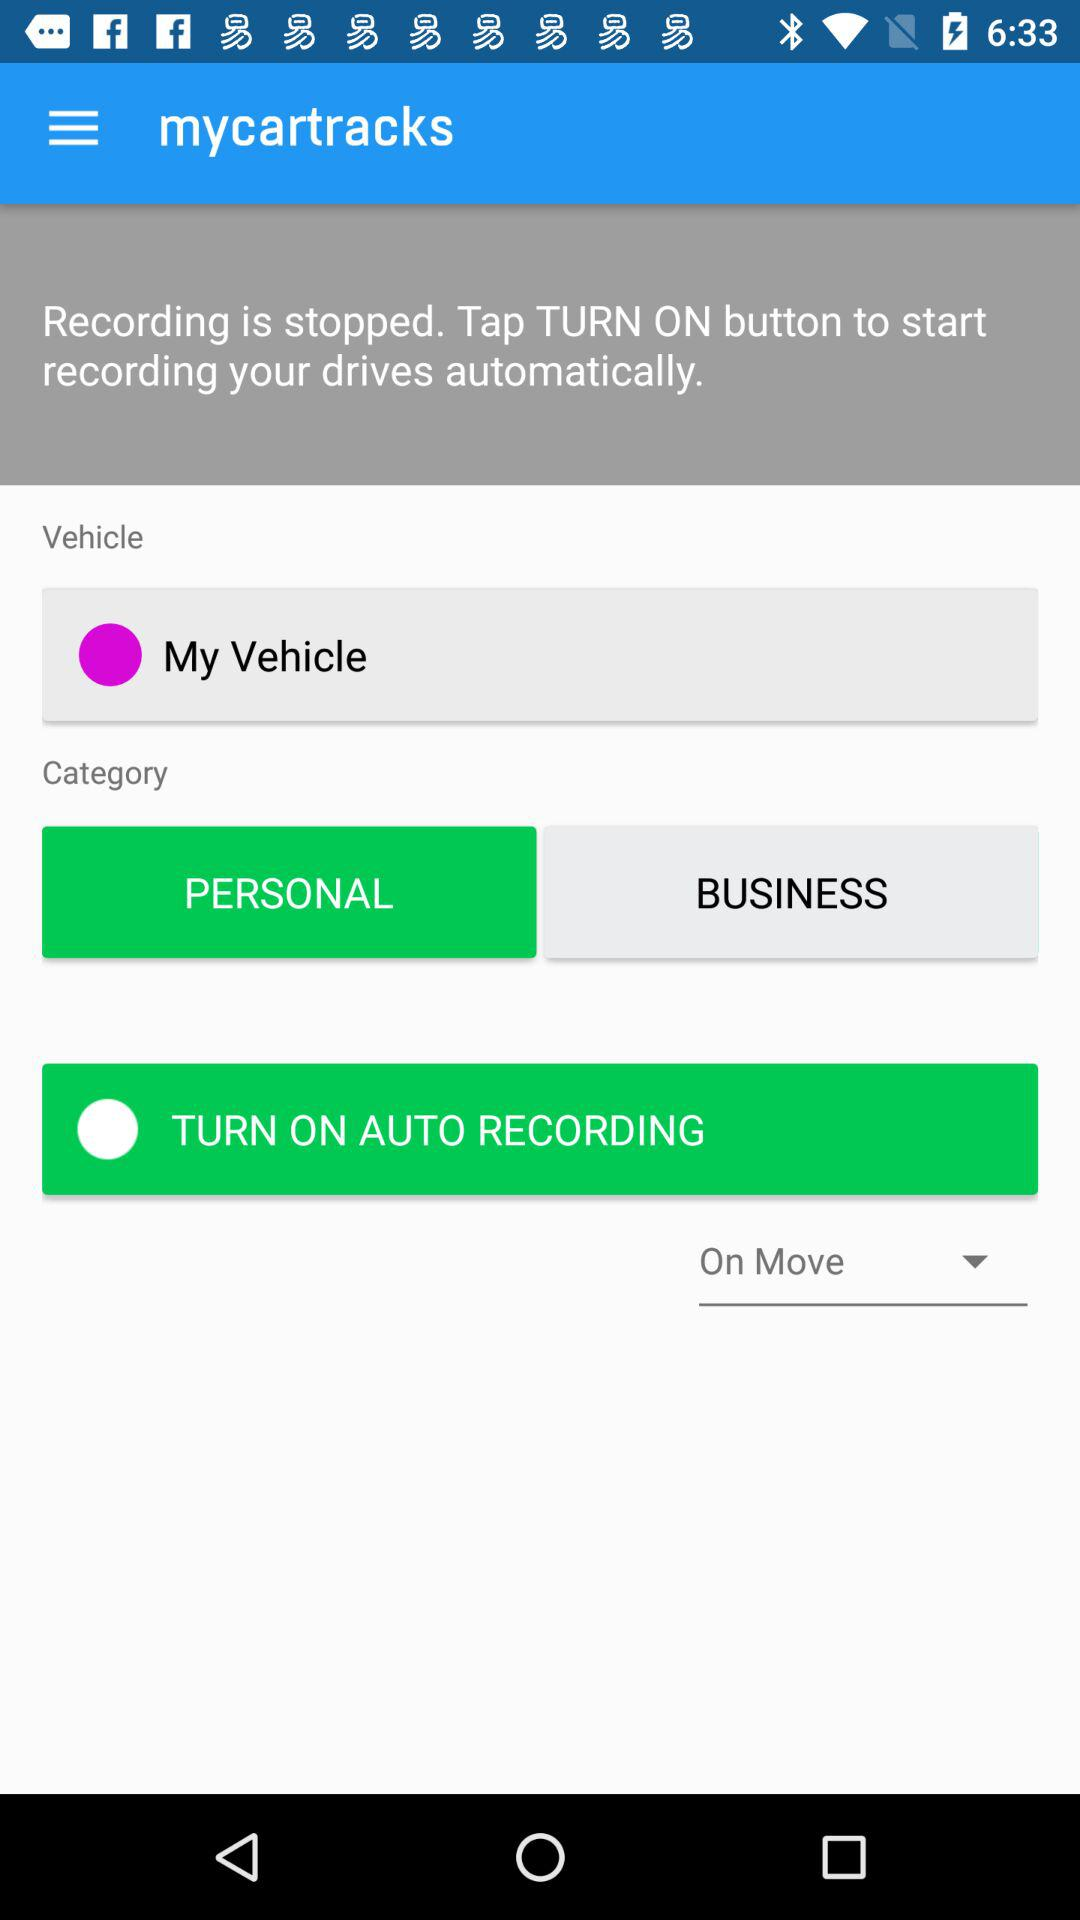What is the status of Auto Recording?
When the provided information is insufficient, respond with <no answer>. <no answer> 